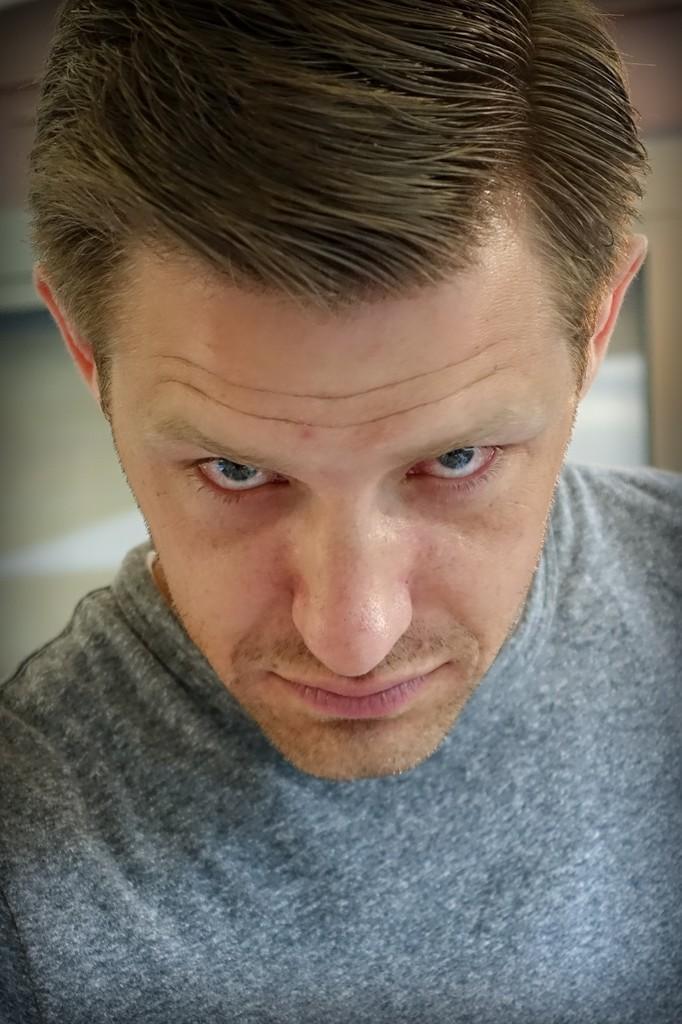How would you summarize this image in a sentence or two? In this image I can see there is a person standing. And at the back it looks like a window. 